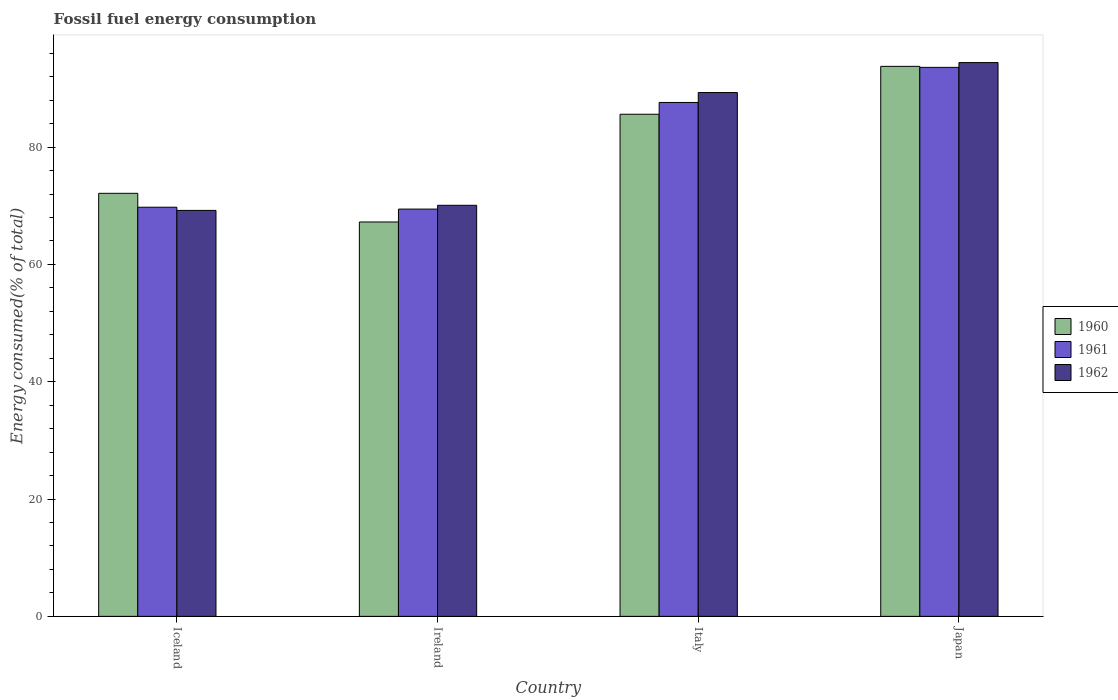How many groups of bars are there?
Your response must be concise. 4. Are the number of bars on each tick of the X-axis equal?
Provide a short and direct response. Yes. What is the label of the 2nd group of bars from the left?
Make the answer very short. Ireland. In how many cases, is the number of bars for a given country not equal to the number of legend labels?
Offer a very short reply. 0. What is the percentage of energy consumed in 1962 in Iceland?
Keep it short and to the point. 69.22. Across all countries, what is the maximum percentage of energy consumed in 1962?
Make the answer very short. 94.42. Across all countries, what is the minimum percentage of energy consumed in 1962?
Make the answer very short. 69.22. In which country was the percentage of energy consumed in 1961 maximum?
Your answer should be very brief. Japan. What is the total percentage of energy consumed in 1960 in the graph?
Your answer should be compact. 318.76. What is the difference between the percentage of energy consumed in 1962 in Iceland and that in Ireland?
Offer a terse response. -0.87. What is the difference between the percentage of energy consumed in 1960 in Iceland and the percentage of energy consumed in 1962 in Japan?
Give a very brief answer. -22.29. What is the average percentage of energy consumed in 1962 per country?
Your answer should be compact. 80.76. What is the difference between the percentage of energy consumed of/in 1960 and percentage of energy consumed of/in 1962 in Ireland?
Ensure brevity in your answer.  -2.84. What is the ratio of the percentage of energy consumed in 1962 in Ireland to that in Italy?
Offer a very short reply. 0.78. Is the difference between the percentage of energy consumed in 1960 in Iceland and Japan greater than the difference between the percentage of energy consumed in 1962 in Iceland and Japan?
Offer a terse response. Yes. What is the difference between the highest and the second highest percentage of energy consumed in 1962?
Offer a terse response. -19.23. What is the difference between the highest and the lowest percentage of energy consumed in 1962?
Offer a terse response. 25.2. What does the 3rd bar from the left in Iceland represents?
Provide a short and direct response. 1962. What does the 2nd bar from the right in Japan represents?
Your answer should be very brief. 1961. Are the values on the major ticks of Y-axis written in scientific E-notation?
Your answer should be very brief. No. Where does the legend appear in the graph?
Give a very brief answer. Center right. How many legend labels are there?
Your answer should be very brief. 3. What is the title of the graph?
Offer a terse response. Fossil fuel energy consumption. Does "1982" appear as one of the legend labels in the graph?
Your response must be concise. No. What is the label or title of the Y-axis?
Your response must be concise. Energy consumed(% of total). What is the Energy consumed(% of total) of 1960 in Iceland?
Your answer should be compact. 72.13. What is the Energy consumed(% of total) of 1961 in Iceland?
Provide a short and direct response. 69.76. What is the Energy consumed(% of total) in 1962 in Iceland?
Keep it short and to the point. 69.22. What is the Energy consumed(% of total) of 1960 in Ireland?
Offer a very short reply. 67.24. What is the Energy consumed(% of total) in 1961 in Ireland?
Your answer should be very brief. 69.44. What is the Energy consumed(% of total) of 1962 in Ireland?
Make the answer very short. 70.09. What is the Energy consumed(% of total) of 1960 in Italy?
Your answer should be very brief. 85.61. What is the Energy consumed(% of total) in 1961 in Italy?
Make the answer very short. 87.62. What is the Energy consumed(% of total) of 1962 in Italy?
Make the answer very short. 89.31. What is the Energy consumed(% of total) in 1960 in Japan?
Ensure brevity in your answer.  93.78. What is the Energy consumed(% of total) in 1961 in Japan?
Make the answer very short. 93.6. What is the Energy consumed(% of total) of 1962 in Japan?
Provide a succinct answer. 94.42. Across all countries, what is the maximum Energy consumed(% of total) in 1960?
Your answer should be very brief. 93.78. Across all countries, what is the maximum Energy consumed(% of total) in 1961?
Offer a very short reply. 93.6. Across all countries, what is the maximum Energy consumed(% of total) of 1962?
Your answer should be very brief. 94.42. Across all countries, what is the minimum Energy consumed(% of total) of 1960?
Make the answer very short. 67.24. Across all countries, what is the minimum Energy consumed(% of total) of 1961?
Your answer should be compact. 69.44. Across all countries, what is the minimum Energy consumed(% of total) of 1962?
Your answer should be compact. 69.22. What is the total Energy consumed(% of total) in 1960 in the graph?
Give a very brief answer. 318.76. What is the total Energy consumed(% of total) of 1961 in the graph?
Your answer should be compact. 320.42. What is the total Energy consumed(% of total) of 1962 in the graph?
Keep it short and to the point. 323.04. What is the difference between the Energy consumed(% of total) in 1960 in Iceland and that in Ireland?
Provide a succinct answer. 4.89. What is the difference between the Energy consumed(% of total) of 1961 in Iceland and that in Ireland?
Offer a terse response. 0.32. What is the difference between the Energy consumed(% of total) in 1962 in Iceland and that in Ireland?
Your answer should be very brief. -0.87. What is the difference between the Energy consumed(% of total) of 1960 in Iceland and that in Italy?
Make the answer very short. -13.48. What is the difference between the Energy consumed(% of total) in 1961 in Iceland and that in Italy?
Offer a very short reply. -17.86. What is the difference between the Energy consumed(% of total) in 1962 in Iceland and that in Italy?
Offer a terse response. -20.09. What is the difference between the Energy consumed(% of total) of 1960 in Iceland and that in Japan?
Give a very brief answer. -21.65. What is the difference between the Energy consumed(% of total) of 1961 in Iceland and that in Japan?
Offer a terse response. -23.85. What is the difference between the Energy consumed(% of total) of 1962 in Iceland and that in Japan?
Provide a succinct answer. -25.2. What is the difference between the Energy consumed(% of total) in 1960 in Ireland and that in Italy?
Your response must be concise. -18.37. What is the difference between the Energy consumed(% of total) in 1961 in Ireland and that in Italy?
Provide a succinct answer. -18.18. What is the difference between the Energy consumed(% of total) in 1962 in Ireland and that in Italy?
Your answer should be very brief. -19.23. What is the difference between the Energy consumed(% of total) in 1960 in Ireland and that in Japan?
Offer a terse response. -26.53. What is the difference between the Energy consumed(% of total) of 1961 in Ireland and that in Japan?
Your answer should be very brief. -24.16. What is the difference between the Energy consumed(% of total) in 1962 in Ireland and that in Japan?
Your answer should be very brief. -24.34. What is the difference between the Energy consumed(% of total) in 1960 in Italy and that in Japan?
Give a very brief answer. -8.17. What is the difference between the Energy consumed(% of total) in 1961 in Italy and that in Japan?
Your answer should be compact. -5.99. What is the difference between the Energy consumed(% of total) in 1962 in Italy and that in Japan?
Keep it short and to the point. -5.11. What is the difference between the Energy consumed(% of total) in 1960 in Iceland and the Energy consumed(% of total) in 1961 in Ireland?
Provide a short and direct response. 2.69. What is the difference between the Energy consumed(% of total) of 1960 in Iceland and the Energy consumed(% of total) of 1962 in Ireland?
Provide a succinct answer. 2.04. What is the difference between the Energy consumed(% of total) in 1961 in Iceland and the Energy consumed(% of total) in 1962 in Ireland?
Provide a succinct answer. -0.33. What is the difference between the Energy consumed(% of total) in 1960 in Iceland and the Energy consumed(% of total) in 1961 in Italy?
Offer a very short reply. -15.49. What is the difference between the Energy consumed(% of total) of 1960 in Iceland and the Energy consumed(% of total) of 1962 in Italy?
Ensure brevity in your answer.  -17.18. What is the difference between the Energy consumed(% of total) of 1961 in Iceland and the Energy consumed(% of total) of 1962 in Italy?
Give a very brief answer. -19.55. What is the difference between the Energy consumed(% of total) in 1960 in Iceland and the Energy consumed(% of total) in 1961 in Japan?
Offer a very short reply. -21.48. What is the difference between the Energy consumed(% of total) in 1960 in Iceland and the Energy consumed(% of total) in 1962 in Japan?
Offer a terse response. -22.29. What is the difference between the Energy consumed(% of total) in 1961 in Iceland and the Energy consumed(% of total) in 1962 in Japan?
Your answer should be very brief. -24.66. What is the difference between the Energy consumed(% of total) of 1960 in Ireland and the Energy consumed(% of total) of 1961 in Italy?
Your response must be concise. -20.38. What is the difference between the Energy consumed(% of total) in 1960 in Ireland and the Energy consumed(% of total) in 1962 in Italy?
Provide a short and direct response. -22.07. What is the difference between the Energy consumed(% of total) of 1961 in Ireland and the Energy consumed(% of total) of 1962 in Italy?
Ensure brevity in your answer.  -19.87. What is the difference between the Energy consumed(% of total) of 1960 in Ireland and the Energy consumed(% of total) of 1961 in Japan?
Provide a succinct answer. -26.36. What is the difference between the Energy consumed(% of total) in 1960 in Ireland and the Energy consumed(% of total) in 1962 in Japan?
Your answer should be compact. -27.18. What is the difference between the Energy consumed(% of total) in 1961 in Ireland and the Energy consumed(% of total) in 1962 in Japan?
Offer a terse response. -24.98. What is the difference between the Energy consumed(% of total) of 1960 in Italy and the Energy consumed(% of total) of 1961 in Japan?
Your response must be concise. -7.99. What is the difference between the Energy consumed(% of total) of 1960 in Italy and the Energy consumed(% of total) of 1962 in Japan?
Offer a terse response. -8.81. What is the difference between the Energy consumed(% of total) of 1961 in Italy and the Energy consumed(% of total) of 1962 in Japan?
Keep it short and to the point. -6.8. What is the average Energy consumed(% of total) of 1960 per country?
Make the answer very short. 79.69. What is the average Energy consumed(% of total) of 1961 per country?
Ensure brevity in your answer.  80.1. What is the average Energy consumed(% of total) in 1962 per country?
Your response must be concise. 80.76. What is the difference between the Energy consumed(% of total) of 1960 and Energy consumed(% of total) of 1961 in Iceland?
Ensure brevity in your answer.  2.37. What is the difference between the Energy consumed(% of total) of 1960 and Energy consumed(% of total) of 1962 in Iceland?
Your answer should be compact. 2.91. What is the difference between the Energy consumed(% of total) of 1961 and Energy consumed(% of total) of 1962 in Iceland?
Provide a succinct answer. 0.54. What is the difference between the Energy consumed(% of total) of 1960 and Energy consumed(% of total) of 1961 in Ireland?
Your answer should be compact. -2.2. What is the difference between the Energy consumed(% of total) of 1960 and Energy consumed(% of total) of 1962 in Ireland?
Make the answer very short. -2.84. What is the difference between the Energy consumed(% of total) in 1961 and Energy consumed(% of total) in 1962 in Ireland?
Your answer should be compact. -0.65. What is the difference between the Energy consumed(% of total) of 1960 and Energy consumed(% of total) of 1961 in Italy?
Your answer should be very brief. -2.01. What is the difference between the Energy consumed(% of total) of 1960 and Energy consumed(% of total) of 1962 in Italy?
Ensure brevity in your answer.  -3.7. What is the difference between the Energy consumed(% of total) in 1961 and Energy consumed(% of total) in 1962 in Italy?
Make the answer very short. -1.69. What is the difference between the Energy consumed(% of total) in 1960 and Energy consumed(% of total) in 1961 in Japan?
Ensure brevity in your answer.  0.17. What is the difference between the Energy consumed(% of total) in 1960 and Energy consumed(% of total) in 1962 in Japan?
Provide a short and direct response. -0.64. What is the difference between the Energy consumed(% of total) of 1961 and Energy consumed(% of total) of 1962 in Japan?
Keep it short and to the point. -0.82. What is the ratio of the Energy consumed(% of total) of 1960 in Iceland to that in Ireland?
Your answer should be very brief. 1.07. What is the ratio of the Energy consumed(% of total) of 1962 in Iceland to that in Ireland?
Keep it short and to the point. 0.99. What is the ratio of the Energy consumed(% of total) of 1960 in Iceland to that in Italy?
Ensure brevity in your answer.  0.84. What is the ratio of the Energy consumed(% of total) of 1961 in Iceland to that in Italy?
Offer a very short reply. 0.8. What is the ratio of the Energy consumed(% of total) in 1962 in Iceland to that in Italy?
Make the answer very short. 0.78. What is the ratio of the Energy consumed(% of total) of 1960 in Iceland to that in Japan?
Provide a succinct answer. 0.77. What is the ratio of the Energy consumed(% of total) in 1961 in Iceland to that in Japan?
Keep it short and to the point. 0.75. What is the ratio of the Energy consumed(% of total) of 1962 in Iceland to that in Japan?
Your response must be concise. 0.73. What is the ratio of the Energy consumed(% of total) of 1960 in Ireland to that in Italy?
Your answer should be very brief. 0.79. What is the ratio of the Energy consumed(% of total) in 1961 in Ireland to that in Italy?
Your response must be concise. 0.79. What is the ratio of the Energy consumed(% of total) of 1962 in Ireland to that in Italy?
Your answer should be very brief. 0.78. What is the ratio of the Energy consumed(% of total) of 1960 in Ireland to that in Japan?
Provide a short and direct response. 0.72. What is the ratio of the Energy consumed(% of total) of 1961 in Ireland to that in Japan?
Ensure brevity in your answer.  0.74. What is the ratio of the Energy consumed(% of total) in 1962 in Ireland to that in Japan?
Offer a very short reply. 0.74. What is the ratio of the Energy consumed(% of total) in 1960 in Italy to that in Japan?
Keep it short and to the point. 0.91. What is the ratio of the Energy consumed(% of total) in 1961 in Italy to that in Japan?
Offer a terse response. 0.94. What is the ratio of the Energy consumed(% of total) of 1962 in Italy to that in Japan?
Your response must be concise. 0.95. What is the difference between the highest and the second highest Energy consumed(% of total) in 1960?
Provide a succinct answer. 8.17. What is the difference between the highest and the second highest Energy consumed(% of total) in 1961?
Ensure brevity in your answer.  5.99. What is the difference between the highest and the second highest Energy consumed(% of total) of 1962?
Make the answer very short. 5.11. What is the difference between the highest and the lowest Energy consumed(% of total) of 1960?
Provide a short and direct response. 26.53. What is the difference between the highest and the lowest Energy consumed(% of total) of 1961?
Make the answer very short. 24.16. What is the difference between the highest and the lowest Energy consumed(% of total) in 1962?
Your answer should be compact. 25.2. 